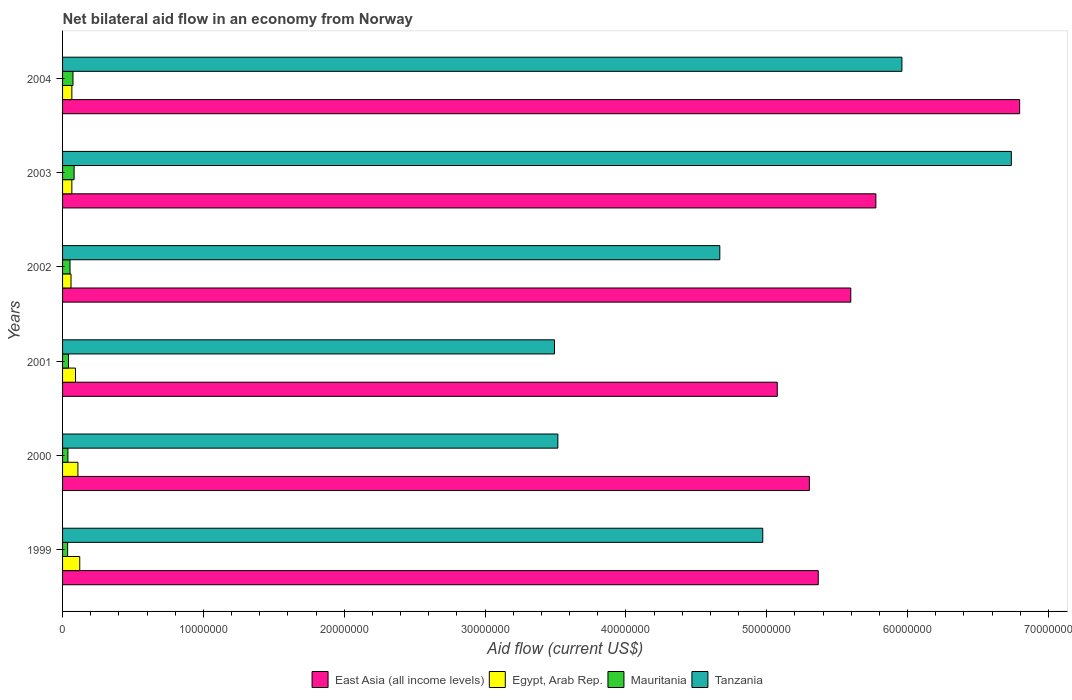How many different coloured bars are there?
Give a very brief answer. 4. How many groups of bars are there?
Offer a terse response. 6. How many bars are there on the 5th tick from the top?
Your answer should be very brief. 4. How many bars are there on the 5th tick from the bottom?
Provide a succinct answer. 4. What is the label of the 6th group of bars from the top?
Give a very brief answer. 1999. What is the net bilateral aid flow in Mauritania in 2004?
Offer a terse response. 7.40e+05. Across all years, what is the maximum net bilateral aid flow in Tanzania?
Provide a succinct answer. 6.74e+07. Across all years, what is the minimum net bilateral aid flow in Egypt, Arab Rep.?
Ensure brevity in your answer.  6.00e+05. In which year was the net bilateral aid flow in Tanzania maximum?
Give a very brief answer. 2003. In which year was the net bilateral aid flow in Tanzania minimum?
Offer a very short reply. 2001. What is the total net bilateral aid flow in Mauritania in the graph?
Offer a terse response. 3.25e+06. What is the difference between the net bilateral aid flow in Egypt, Arab Rep. in 2001 and the net bilateral aid flow in Mauritania in 2003?
Provide a succinct answer. 1.00e+05. What is the average net bilateral aid flow in Tanzania per year?
Offer a very short reply. 4.89e+07. In the year 2002, what is the difference between the net bilateral aid flow in Tanzania and net bilateral aid flow in East Asia (all income levels)?
Your answer should be very brief. -9.30e+06. In how many years, is the net bilateral aid flow in Mauritania greater than 56000000 US$?
Offer a terse response. 0. What is the ratio of the net bilateral aid flow in East Asia (all income levels) in 2000 to that in 2001?
Offer a terse response. 1.04. Is the net bilateral aid flow in Mauritania in 2000 less than that in 2003?
Ensure brevity in your answer.  Yes. What is the difference between the highest and the lowest net bilateral aid flow in Mauritania?
Provide a short and direct response. 4.60e+05. In how many years, is the net bilateral aid flow in Egypt, Arab Rep. greater than the average net bilateral aid flow in Egypt, Arab Rep. taken over all years?
Keep it short and to the point. 3. Is the sum of the net bilateral aid flow in Egypt, Arab Rep. in 2000 and 2004 greater than the maximum net bilateral aid flow in East Asia (all income levels) across all years?
Keep it short and to the point. No. Is it the case that in every year, the sum of the net bilateral aid flow in Egypt, Arab Rep. and net bilateral aid flow in Tanzania is greater than the sum of net bilateral aid flow in Mauritania and net bilateral aid flow in East Asia (all income levels)?
Offer a terse response. No. What does the 3rd bar from the top in 2003 represents?
Offer a very short reply. Egypt, Arab Rep. What does the 3rd bar from the bottom in 2000 represents?
Ensure brevity in your answer.  Mauritania. How many bars are there?
Your answer should be very brief. 24. Are all the bars in the graph horizontal?
Your answer should be very brief. Yes. Does the graph contain any zero values?
Your answer should be very brief. No. How are the legend labels stacked?
Provide a short and direct response. Horizontal. What is the title of the graph?
Make the answer very short. Net bilateral aid flow in an economy from Norway. Does "Rwanda" appear as one of the legend labels in the graph?
Ensure brevity in your answer.  No. What is the label or title of the X-axis?
Offer a terse response. Aid flow (current US$). What is the Aid flow (current US$) in East Asia (all income levels) in 1999?
Your response must be concise. 5.37e+07. What is the Aid flow (current US$) of Egypt, Arab Rep. in 1999?
Make the answer very short. 1.22e+06. What is the Aid flow (current US$) of Mauritania in 1999?
Keep it short and to the point. 3.60e+05. What is the Aid flow (current US$) of Tanzania in 1999?
Your response must be concise. 4.97e+07. What is the Aid flow (current US$) in East Asia (all income levels) in 2000?
Your answer should be very brief. 5.30e+07. What is the Aid flow (current US$) in Egypt, Arab Rep. in 2000?
Offer a terse response. 1.09e+06. What is the Aid flow (current US$) of Mauritania in 2000?
Ensure brevity in your answer.  3.80e+05. What is the Aid flow (current US$) in Tanzania in 2000?
Provide a succinct answer. 3.52e+07. What is the Aid flow (current US$) in East Asia (all income levels) in 2001?
Keep it short and to the point. 5.08e+07. What is the Aid flow (current US$) in Egypt, Arab Rep. in 2001?
Provide a short and direct response. 9.20e+05. What is the Aid flow (current US$) in Tanzania in 2001?
Offer a terse response. 3.49e+07. What is the Aid flow (current US$) in East Asia (all income levels) in 2002?
Offer a very short reply. 5.60e+07. What is the Aid flow (current US$) in Mauritania in 2002?
Offer a very short reply. 5.30e+05. What is the Aid flow (current US$) in Tanzania in 2002?
Offer a very short reply. 4.67e+07. What is the Aid flow (current US$) of East Asia (all income levels) in 2003?
Your response must be concise. 5.78e+07. What is the Aid flow (current US$) of Mauritania in 2003?
Your answer should be compact. 8.20e+05. What is the Aid flow (current US$) of Tanzania in 2003?
Ensure brevity in your answer.  6.74e+07. What is the Aid flow (current US$) of East Asia (all income levels) in 2004?
Make the answer very short. 6.80e+07. What is the Aid flow (current US$) in Mauritania in 2004?
Offer a very short reply. 7.40e+05. What is the Aid flow (current US$) of Tanzania in 2004?
Your answer should be compact. 5.96e+07. Across all years, what is the maximum Aid flow (current US$) of East Asia (all income levels)?
Provide a short and direct response. 6.80e+07. Across all years, what is the maximum Aid flow (current US$) of Egypt, Arab Rep.?
Provide a short and direct response. 1.22e+06. Across all years, what is the maximum Aid flow (current US$) of Mauritania?
Give a very brief answer. 8.20e+05. Across all years, what is the maximum Aid flow (current US$) in Tanzania?
Offer a terse response. 6.74e+07. Across all years, what is the minimum Aid flow (current US$) in East Asia (all income levels)?
Make the answer very short. 5.08e+07. Across all years, what is the minimum Aid flow (current US$) in Mauritania?
Offer a terse response. 3.60e+05. Across all years, what is the minimum Aid flow (current US$) in Tanzania?
Offer a very short reply. 3.49e+07. What is the total Aid flow (current US$) of East Asia (all income levels) in the graph?
Keep it short and to the point. 3.39e+08. What is the total Aid flow (current US$) in Egypt, Arab Rep. in the graph?
Your response must be concise. 5.15e+06. What is the total Aid flow (current US$) in Mauritania in the graph?
Ensure brevity in your answer.  3.25e+06. What is the total Aid flow (current US$) of Tanzania in the graph?
Your answer should be very brief. 2.93e+08. What is the difference between the Aid flow (current US$) of East Asia (all income levels) in 1999 and that in 2000?
Offer a very short reply. 6.30e+05. What is the difference between the Aid flow (current US$) of Mauritania in 1999 and that in 2000?
Provide a succinct answer. -2.00e+04. What is the difference between the Aid flow (current US$) in Tanzania in 1999 and that in 2000?
Your answer should be compact. 1.46e+07. What is the difference between the Aid flow (current US$) in East Asia (all income levels) in 1999 and that in 2001?
Provide a short and direct response. 2.91e+06. What is the difference between the Aid flow (current US$) of Mauritania in 1999 and that in 2001?
Ensure brevity in your answer.  -6.00e+04. What is the difference between the Aid flow (current US$) of Tanzania in 1999 and that in 2001?
Keep it short and to the point. 1.48e+07. What is the difference between the Aid flow (current US$) in East Asia (all income levels) in 1999 and that in 2002?
Ensure brevity in your answer.  -2.31e+06. What is the difference between the Aid flow (current US$) in Egypt, Arab Rep. in 1999 and that in 2002?
Offer a very short reply. 6.20e+05. What is the difference between the Aid flow (current US$) of Mauritania in 1999 and that in 2002?
Make the answer very short. -1.70e+05. What is the difference between the Aid flow (current US$) of Tanzania in 1999 and that in 2002?
Provide a succinct answer. 3.05e+06. What is the difference between the Aid flow (current US$) in East Asia (all income levels) in 1999 and that in 2003?
Keep it short and to the point. -4.09e+06. What is the difference between the Aid flow (current US$) in Egypt, Arab Rep. in 1999 and that in 2003?
Offer a very short reply. 5.60e+05. What is the difference between the Aid flow (current US$) in Mauritania in 1999 and that in 2003?
Offer a very short reply. -4.60e+05. What is the difference between the Aid flow (current US$) of Tanzania in 1999 and that in 2003?
Make the answer very short. -1.76e+07. What is the difference between the Aid flow (current US$) of East Asia (all income levels) in 1999 and that in 2004?
Provide a short and direct response. -1.43e+07. What is the difference between the Aid flow (current US$) in Egypt, Arab Rep. in 1999 and that in 2004?
Give a very brief answer. 5.60e+05. What is the difference between the Aid flow (current US$) in Mauritania in 1999 and that in 2004?
Offer a terse response. -3.80e+05. What is the difference between the Aid flow (current US$) in Tanzania in 1999 and that in 2004?
Offer a terse response. -9.88e+06. What is the difference between the Aid flow (current US$) in East Asia (all income levels) in 2000 and that in 2001?
Your answer should be compact. 2.28e+06. What is the difference between the Aid flow (current US$) of Egypt, Arab Rep. in 2000 and that in 2001?
Make the answer very short. 1.70e+05. What is the difference between the Aid flow (current US$) of Tanzania in 2000 and that in 2001?
Your answer should be compact. 2.40e+05. What is the difference between the Aid flow (current US$) of East Asia (all income levels) in 2000 and that in 2002?
Make the answer very short. -2.94e+06. What is the difference between the Aid flow (current US$) in Tanzania in 2000 and that in 2002?
Offer a terse response. -1.15e+07. What is the difference between the Aid flow (current US$) in East Asia (all income levels) in 2000 and that in 2003?
Provide a short and direct response. -4.72e+06. What is the difference between the Aid flow (current US$) of Egypt, Arab Rep. in 2000 and that in 2003?
Your answer should be very brief. 4.30e+05. What is the difference between the Aid flow (current US$) of Mauritania in 2000 and that in 2003?
Offer a terse response. -4.40e+05. What is the difference between the Aid flow (current US$) of Tanzania in 2000 and that in 2003?
Make the answer very short. -3.22e+07. What is the difference between the Aid flow (current US$) in East Asia (all income levels) in 2000 and that in 2004?
Keep it short and to the point. -1.49e+07. What is the difference between the Aid flow (current US$) of Mauritania in 2000 and that in 2004?
Your response must be concise. -3.60e+05. What is the difference between the Aid flow (current US$) in Tanzania in 2000 and that in 2004?
Your answer should be very brief. -2.44e+07. What is the difference between the Aid flow (current US$) in East Asia (all income levels) in 2001 and that in 2002?
Give a very brief answer. -5.22e+06. What is the difference between the Aid flow (current US$) of Egypt, Arab Rep. in 2001 and that in 2002?
Your answer should be very brief. 3.20e+05. What is the difference between the Aid flow (current US$) in Mauritania in 2001 and that in 2002?
Ensure brevity in your answer.  -1.10e+05. What is the difference between the Aid flow (current US$) in Tanzania in 2001 and that in 2002?
Offer a terse response. -1.17e+07. What is the difference between the Aid flow (current US$) of East Asia (all income levels) in 2001 and that in 2003?
Ensure brevity in your answer.  -7.00e+06. What is the difference between the Aid flow (current US$) of Egypt, Arab Rep. in 2001 and that in 2003?
Provide a succinct answer. 2.60e+05. What is the difference between the Aid flow (current US$) in Mauritania in 2001 and that in 2003?
Offer a very short reply. -4.00e+05. What is the difference between the Aid flow (current US$) in Tanzania in 2001 and that in 2003?
Make the answer very short. -3.24e+07. What is the difference between the Aid flow (current US$) in East Asia (all income levels) in 2001 and that in 2004?
Your response must be concise. -1.72e+07. What is the difference between the Aid flow (current US$) in Mauritania in 2001 and that in 2004?
Give a very brief answer. -3.20e+05. What is the difference between the Aid flow (current US$) of Tanzania in 2001 and that in 2004?
Keep it short and to the point. -2.47e+07. What is the difference between the Aid flow (current US$) of East Asia (all income levels) in 2002 and that in 2003?
Provide a short and direct response. -1.78e+06. What is the difference between the Aid flow (current US$) in Mauritania in 2002 and that in 2003?
Offer a very short reply. -2.90e+05. What is the difference between the Aid flow (current US$) of Tanzania in 2002 and that in 2003?
Offer a very short reply. -2.07e+07. What is the difference between the Aid flow (current US$) of East Asia (all income levels) in 2002 and that in 2004?
Your response must be concise. -1.20e+07. What is the difference between the Aid flow (current US$) in Egypt, Arab Rep. in 2002 and that in 2004?
Ensure brevity in your answer.  -6.00e+04. What is the difference between the Aid flow (current US$) in Mauritania in 2002 and that in 2004?
Offer a terse response. -2.10e+05. What is the difference between the Aid flow (current US$) of Tanzania in 2002 and that in 2004?
Make the answer very short. -1.29e+07. What is the difference between the Aid flow (current US$) of East Asia (all income levels) in 2003 and that in 2004?
Make the answer very short. -1.02e+07. What is the difference between the Aid flow (current US$) of Egypt, Arab Rep. in 2003 and that in 2004?
Give a very brief answer. 0. What is the difference between the Aid flow (current US$) in Mauritania in 2003 and that in 2004?
Offer a terse response. 8.00e+04. What is the difference between the Aid flow (current US$) in Tanzania in 2003 and that in 2004?
Give a very brief answer. 7.77e+06. What is the difference between the Aid flow (current US$) in East Asia (all income levels) in 1999 and the Aid flow (current US$) in Egypt, Arab Rep. in 2000?
Your answer should be very brief. 5.26e+07. What is the difference between the Aid flow (current US$) of East Asia (all income levels) in 1999 and the Aid flow (current US$) of Mauritania in 2000?
Make the answer very short. 5.33e+07. What is the difference between the Aid flow (current US$) of East Asia (all income levels) in 1999 and the Aid flow (current US$) of Tanzania in 2000?
Your answer should be very brief. 1.85e+07. What is the difference between the Aid flow (current US$) of Egypt, Arab Rep. in 1999 and the Aid flow (current US$) of Mauritania in 2000?
Give a very brief answer. 8.40e+05. What is the difference between the Aid flow (current US$) in Egypt, Arab Rep. in 1999 and the Aid flow (current US$) in Tanzania in 2000?
Your response must be concise. -3.40e+07. What is the difference between the Aid flow (current US$) of Mauritania in 1999 and the Aid flow (current US$) of Tanzania in 2000?
Your answer should be very brief. -3.48e+07. What is the difference between the Aid flow (current US$) in East Asia (all income levels) in 1999 and the Aid flow (current US$) in Egypt, Arab Rep. in 2001?
Offer a terse response. 5.27e+07. What is the difference between the Aid flow (current US$) of East Asia (all income levels) in 1999 and the Aid flow (current US$) of Mauritania in 2001?
Provide a short and direct response. 5.32e+07. What is the difference between the Aid flow (current US$) in East Asia (all income levels) in 1999 and the Aid flow (current US$) in Tanzania in 2001?
Provide a short and direct response. 1.87e+07. What is the difference between the Aid flow (current US$) of Egypt, Arab Rep. in 1999 and the Aid flow (current US$) of Mauritania in 2001?
Give a very brief answer. 8.00e+05. What is the difference between the Aid flow (current US$) in Egypt, Arab Rep. in 1999 and the Aid flow (current US$) in Tanzania in 2001?
Offer a very short reply. -3.37e+07. What is the difference between the Aid flow (current US$) of Mauritania in 1999 and the Aid flow (current US$) of Tanzania in 2001?
Keep it short and to the point. -3.46e+07. What is the difference between the Aid flow (current US$) of East Asia (all income levels) in 1999 and the Aid flow (current US$) of Egypt, Arab Rep. in 2002?
Your response must be concise. 5.31e+07. What is the difference between the Aid flow (current US$) in East Asia (all income levels) in 1999 and the Aid flow (current US$) in Mauritania in 2002?
Offer a very short reply. 5.31e+07. What is the difference between the Aid flow (current US$) in East Asia (all income levels) in 1999 and the Aid flow (current US$) in Tanzania in 2002?
Make the answer very short. 6.99e+06. What is the difference between the Aid flow (current US$) of Egypt, Arab Rep. in 1999 and the Aid flow (current US$) of Mauritania in 2002?
Keep it short and to the point. 6.90e+05. What is the difference between the Aid flow (current US$) in Egypt, Arab Rep. in 1999 and the Aid flow (current US$) in Tanzania in 2002?
Offer a terse response. -4.54e+07. What is the difference between the Aid flow (current US$) in Mauritania in 1999 and the Aid flow (current US$) in Tanzania in 2002?
Provide a short and direct response. -4.63e+07. What is the difference between the Aid flow (current US$) in East Asia (all income levels) in 1999 and the Aid flow (current US$) in Egypt, Arab Rep. in 2003?
Your answer should be compact. 5.30e+07. What is the difference between the Aid flow (current US$) of East Asia (all income levels) in 1999 and the Aid flow (current US$) of Mauritania in 2003?
Keep it short and to the point. 5.28e+07. What is the difference between the Aid flow (current US$) in East Asia (all income levels) in 1999 and the Aid flow (current US$) in Tanzania in 2003?
Provide a succinct answer. -1.37e+07. What is the difference between the Aid flow (current US$) of Egypt, Arab Rep. in 1999 and the Aid flow (current US$) of Tanzania in 2003?
Offer a very short reply. -6.62e+07. What is the difference between the Aid flow (current US$) in Mauritania in 1999 and the Aid flow (current US$) in Tanzania in 2003?
Provide a short and direct response. -6.70e+07. What is the difference between the Aid flow (current US$) in East Asia (all income levels) in 1999 and the Aid flow (current US$) in Egypt, Arab Rep. in 2004?
Offer a terse response. 5.30e+07. What is the difference between the Aid flow (current US$) of East Asia (all income levels) in 1999 and the Aid flow (current US$) of Mauritania in 2004?
Your answer should be very brief. 5.29e+07. What is the difference between the Aid flow (current US$) of East Asia (all income levels) in 1999 and the Aid flow (current US$) of Tanzania in 2004?
Provide a short and direct response. -5.94e+06. What is the difference between the Aid flow (current US$) in Egypt, Arab Rep. in 1999 and the Aid flow (current US$) in Tanzania in 2004?
Offer a terse response. -5.84e+07. What is the difference between the Aid flow (current US$) of Mauritania in 1999 and the Aid flow (current US$) of Tanzania in 2004?
Your answer should be compact. -5.92e+07. What is the difference between the Aid flow (current US$) of East Asia (all income levels) in 2000 and the Aid flow (current US$) of Egypt, Arab Rep. in 2001?
Your answer should be very brief. 5.21e+07. What is the difference between the Aid flow (current US$) of East Asia (all income levels) in 2000 and the Aid flow (current US$) of Mauritania in 2001?
Your answer should be compact. 5.26e+07. What is the difference between the Aid flow (current US$) of East Asia (all income levels) in 2000 and the Aid flow (current US$) of Tanzania in 2001?
Your answer should be compact. 1.81e+07. What is the difference between the Aid flow (current US$) of Egypt, Arab Rep. in 2000 and the Aid flow (current US$) of Mauritania in 2001?
Make the answer very short. 6.70e+05. What is the difference between the Aid flow (current US$) in Egypt, Arab Rep. in 2000 and the Aid flow (current US$) in Tanzania in 2001?
Offer a terse response. -3.38e+07. What is the difference between the Aid flow (current US$) in Mauritania in 2000 and the Aid flow (current US$) in Tanzania in 2001?
Keep it short and to the point. -3.46e+07. What is the difference between the Aid flow (current US$) of East Asia (all income levels) in 2000 and the Aid flow (current US$) of Egypt, Arab Rep. in 2002?
Make the answer very short. 5.24e+07. What is the difference between the Aid flow (current US$) of East Asia (all income levels) in 2000 and the Aid flow (current US$) of Mauritania in 2002?
Ensure brevity in your answer.  5.25e+07. What is the difference between the Aid flow (current US$) of East Asia (all income levels) in 2000 and the Aid flow (current US$) of Tanzania in 2002?
Make the answer very short. 6.36e+06. What is the difference between the Aid flow (current US$) in Egypt, Arab Rep. in 2000 and the Aid flow (current US$) in Mauritania in 2002?
Offer a very short reply. 5.60e+05. What is the difference between the Aid flow (current US$) in Egypt, Arab Rep. in 2000 and the Aid flow (current US$) in Tanzania in 2002?
Your response must be concise. -4.56e+07. What is the difference between the Aid flow (current US$) in Mauritania in 2000 and the Aid flow (current US$) in Tanzania in 2002?
Your response must be concise. -4.63e+07. What is the difference between the Aid flow (current US$) of East Asia (all income levels) in 2000 and the Aid flow (current US$) of Egypt, Arab Rep. in 2003?
Your answer should be compact. 5.24e+07. What is the difference between the Aid flow (current US$) in East Asia (all income levels) in 2000 and the Aid flow (current US$) in Mauritania in 2003?
Ensure brevity in your answer.  5.22e+07. What is the difference between the Aid flow (current US$) in East Asia (all income levels) in 2000 and the Aid flow (current US$) in Tanzania in 2003?
Keep it short and to the point. -1.43e+07. What is the difference between the Aid flow (current US$) of Egypt, Arab Rep. in 2000 and the Aid flow (current US$) of Mauritania in 2003?
Offer a very short reply. 2.70e+05. What is the difference between the Aid flow (current US$) in Egypt, Arab Rep. in 2000 and the Aid flow (current US$) in Tanzania in 2003?
Provide a short and direct response. -6.63e+07. What is the difference between the Aid flow (current US$) of Mauritania in 2000 and the Aid flow (current US$) of Tanzania in 2003?
Ensure brevity in your answer.  -6.70e+07. What is the difference between the Aid flow (current US$) in East Asia (all income levels) in 2000 and the Aid flow (current US$) in Egypt, Arab Rep. in 2004?
Your answer should be compact. 5.24e+07. What is the difference between the Aid flow (current US$) of East Asia (all income levels) in 2000 and the Aid flow (current US$) of Mauritania in 2004?
Keep it short and to the point. 5.23e+07. What is the difference between the Aid flow (current US$) in East Asia (all income levels) in 2000 and the Aid flow (current US$) in Tanzania in 2004?
Keep it short and to the point. -6.57e+06. What is the difference between the Aid flow (current US$) in Egypt, Arab Rep. in 2000 and the Aid flow (current US$) in Mauritania in 2004?
Offer a terse response. 3.50e+05. What is the difference between the Aid flow (current US$) in Egypt, Arab Rep. in 2000 and the Aid flow (current US$) in Tanzania in 2004?
Provide a short and direct response. -5.85e+07. What is the difference between the Aid flow (current US$) in Mauritania in 2000 and the Aid flow (current US$) in Tanzania in 2004?
Ensure brevity in your answer.  -5.92e+07. What is the difference between the Aid flow (current US$) of East Asia (all income levels) in 2001 and the Aid flow (current US$) of Egypt, Arab Rep. in 2002?
Keep it short and to the point. 5.02e+07. What is the difference between the Aid flow (current US$) in East Asia (all income levels) in 2001 and the Aid flow (current US$) in Mauritania in 2002?
Your answer should be compact. 5.02e+07. What is the difference between the Aid flow (current US$) in East Asia (all income levels) in 2001 and the Aid flow (current US$) in Tanzania in 2002?
Make the answer very short. 4.08e+06. What is the difference between the Aid flow (current US$) in Egypt, Arab Rep. in 2001 and the Aid flow (current US$) in Mauritania in 2002?
Your answer should be compact. 3.90e+05. What is the difference between the Aid flow (current US$) in Egypt, Arab Rep. in 2001 and the Aid flow (current US$) in Tanzania in 2002?
Make the answer very short. -4.58e+07. What is the difference between the Aid flow (current US$) of Mauritania in 2001 and the Aid flow (current US$) of Tanzania in 2002?
Give a very brief answer. -4.62e+07. What is the difference between the Aid flow (current US$) in East Asia (all income levels) in 2001 and the Aid flow (current US$) in Egypt, Arab Rep. in 2003?
Ensure brevity in your answer.  5.01e+07. What is the difference between the Aid flow (current US$) in East Asia (all income levels) in 2001 and the Aid flow (current US$) in Mauritania in 2003?
Your response must be concise. 4.99e+07. What is the difference between the Aid flow (current US$) in East Asia (all income levels) in 2001 and the Aid flow (current US$) in Tanzania in 2003?
Provide a short and direct response. -1.66e+07. What is the difference between the Aid flow (current US$) of Egypt, Arab Rep. in 2001 and the Aid flow (current US$) of Mauritania in 2003?
Your answer should be compact. 1.00e+05. What is the difference between the Aid flow (current US$) in Egypt, Arab Rep. in 2001 and the Aid flow (current US$) in Tanzania in 2003?
Provide a short and direct response. -6.64e+07. What is the difference between the Aid flow (current US$) in Mauritania in 2001 and the Aid flow (current US$) in Tanzania in 2003?
Your answer should be compact. -6.70e+07. What is the difference between the Aid flow (current US$) of East Asia (all income levels) in 2001 and the Aid flow (current US$) of Egypt, Arab Rep. in 2004?
Offer a very short reply. 5.01e+07. What is the difference between the Aid flow (current US$) of East Asia (all income levels) in 2001 and the Aid flow (current US$) of Mauritania in 2004?
Keep it short and to the point. 5.00e+07. What is the difference between the Aid flow (current US$) of East Asia (all income levels) in 2001 and the Aid flow (current US$) of Tanzania in 2004?
Provide a succinct answer. -8.85e+06. What is the difference between the Aid flow (current US$) in Egypt, Arab Rep. in 2001 and the Aid flow (current US$) in Mauritania in 2004?
Your answer should be compact. 1.80e+05. What is the difference between the Aid flow (current US$) of Egypt, Arab Rep. in 2001 and the Aid flow (current US$) of Tanzania in 2004?
Give a very brief answer. -5.87e+07. What is the difference between the Aid flow (current US$) in Mauritania in 2001 and the Aid flow (current US$) in Tanzania in 2004?
Your response must be concise. -5.92e+07. What is the difference between the Aid flow (current US$) of East Asia (all income levels) in 2002 and the Aid flow (current US$) of Egypt, Arab Rep. in 2003?
Provide a short and direct response. 5.53e+07. What is the difference between the Aid flow (current US$) of East Asia (all income levels) in 2002 and the Aid flow (current US$) of Mauritania in 2003?
Your response must be concise. 5.52e+07. What is the difference between the Aid flow (current US$) in East Asia (all income levels) in 2002 and the Aid flow (current US$) in Tanzania in 2003?
Offer a very short reply. -1.14e+07. What is the difference between the Aid flow (current US$) of Egypt, Arab Rep. in 2002 and the Aid flow (current US$) of Mauritania in 2003?
Give a very brief answer. -2.20e+05. What is the difference between the Aid flow (current US$) of Egypt, Arab Rep. in 2002 and the Aid flow (current US$) of Tanzania in 2003?
Give a very brief answer. -6.68e+07. What is the difference between the Aid flow (current US$) of Mauritania in 2002 and the Aid flow (current US$) of Tanzania in 2003?
Give a very brief answer. -6.68e+07. What is the difference between the Aid flow (current US$) in East Asia (all income levels) in 2002 and the Aid flow (current US$) in Egypt, Arab Rep. in 2004?
Make the answer very short. 5.53e+07. What is the difference between the Aid flow (current US$) of East Asia (all income levels) in 2002 and the Aid flow (current US$) of Mauritania in 2004?
Provide a short and direct response. 5.52e+07. What is the difference between the Aid flow (current US$) of East Asia (all income levels) in 2002 and the Aid flow (current US$) of Tanzania in 2004?
Provide a succinct answer. -3.63e+06. What is the difference between the Aid flow (current US$) of Egypt, Arab Rep. in 2002 and the Aid flow (current US$) of Mauritania in 2004?
Ensure brevity in your answer.  -1.40e+05. What is the difference between the Aid flow (current US$) of Egypt, Arab Rep. in 2002 and the Aid flow (current US$) of Tanzania in 2004?
Provide a short and direct response. -5.90e+07. What is the difference between the Aid flow (current US$) of Mauritania in 2002 and the Aid flow (current US$) of Tanzania in 2004?
Your response must be concise. -5.91e+07. What is the difference between the Aid flow (current US$) of East Asia (all income levels) in 2003 and the Aid flow (current US$) of Egypt, Arab Rep. in 2004?
Provide a short and direct response. 5.71e+07. What is the difference between the Aid flow (current US$) in East Asia (all income levels) in 2003 and the Aid flow (current US$) in Mauritania in 2004?
Ensure brevity in your answer.  5.70e+07. What is the difference between the Aid flow (current US$) in East Asia (all income levels) in 2003 and the Aid flow (current US$) in Tanzania in 2004?
Your answer should be very brief. -1.85e+06. What is the difference between the Aid flow (current US$) of Egypt, Arab Rep. in 2003 and the Aid flow (current US$) of Tanzania in 2004?
Provide a succinct answer. -5.89e+07. What is the difference between the Aid flow (current US$) of Mauritania in 2003 and the Aid flow (current US$) of Tanzania in 2004?
Provide a succinct answer. -5.88e+07. What is the average Aid flow (current US$) of East Asia (all income levels) per year?
Your response must be concise. 5.65e+07. What is the average Aid flow (current US$) of Egypt, Arab Rep. per year?
Your answer should be compact. 8.58e+05. What is the average Aid flow (current US$) of Mauritania per year?
Offer a terse response. 5.42e+05. What is the average Aid flow (current US$) of Tanzania per year?
Provide a short and direct response. 4.89e+07. In the year 1999, what is the difference between the Aid flow (current US$) of East Asia (all income levels) and Aid flow (current US$) of Egypt, Arab Rep.?
Keep it short and to the point. 5.24e+07. In the year 1999, what is the difference between the Aid flow (current US$) in East Asia (all income levels) and Aid flow (current US$) in Mauritania?
Your answer should be compact. 5.33e+07. In the year 1999, what is the difference between the Aid flow (current US$) of East Asia (all income levels) and Aid flow (current US$) of Tanzania?
Make the answer very short. 3.94e+06. In the year 1999, what is the difference between the Aid flow (current US$) of Egypt, Arab Rep. and Aid flow (current US$) of Mauritania?
Keep it short and to the point. 8.60e+05. In the year 1999, what is the difference between the Aid flow (current US$) in Egypt, Arab Rep. and Aid flow (current US$) in Tanzania?
Offer a terse response. -4.85e+07. In the year 1999, what is the difference between the Aid flow (current US$) of Mauritania and Aid flow (current US$) of Tanzania?
Give a very brief answer. -4.94e+07. In the year 2000, what is the difference between the Aid flow (current US$) of East Asia (all income levels) and Aid flow (current US$) of Egypt, Arab Rep.?
Offer a terse response. 5.19e+07. In the year 2000, what is the difference between the Aid flow (current US$) of East Asia (all income levels) and Aid flow (current US$) of Mauritania?
Provide a short and direct response. 5.26e+07. In the year 2000, what is the difference between the Aid flow (current US$) in East Asia (all income levels) and Aid flow (current US$) in Tanzania?
Keep it short and to the point. 1.79e+07. In the year 2000, what is the difference between the Aid flow (current US$) in Egypt, Arab Rep. and Aid flow (current US$) in Mauritania?
Your answer should be very brief. 7.10e+05. In the year 2000, what is the difference between the Aid flow (current US$) in Egypt, Arab Rep. and Aid flow (current US$) in Tanzania?
Ensure brevity in your answer.  -3.41e+07. In the year 2000, what is the difference between the Aid flow (current US$) of Mauritania and Aid flow (current US$) of Tanzania?
Provide a succinct answer. -3.48e+07. In the year 2001, what is the difference between the Aid flow (current US$) in East Asia (all income levels) and Aid flow (current US$) in Egypt, Arab Rep.?
Give a very brief answer. 4.98e+07. In the year 2001, what is the difference between the Aid flow (current US$) in East Asia (all income levels) and Aid flow (current US$) in Mauritania?
Your answer should be very brief. 5.03e+07. In the year 2001, what is the difference between the Aid flow (current US$) of East Asia (all income levels) and Aid flow (current US$) of Tanzania?
Your response must be concise. 1.58e+07. In the year 2001, what is the difference between the Aid flow (current US$) of Egypt, Arab Rep. and Aid flow (current US$) of Tanzania?
Offer a terse response. -3.40e+07. In the year 2001, what is the difference between the Aid flow (current US$) of Mauritania and Aid flow (current US$) of Tanzania?
Your answer should be compact. -3.45e+07. In the year 2002, what is the difference between the Aid flow (current US$) of East Asia (all income levels) and Aid flow (current US$) of Egypt, Arab Rep.?
Make the answer very short. 5.54e+07. In the year 2002, what is the difference between the Aid flow (current US$) of East Asia (all income levels) and Aid flow (current US$) of Mauritania?
Keep it short and to the point. 5.54e+07. In the year 2002, what is the difference between the Aid flow (current US$) in East Asia (all income levels) and Aid flow (current US$) in Tanzania?
Offer a very short reply. 9.30e+06. In the year 2002, what is the difference between the Aid flow (current US$) of Egypt, Arab Rep. and Aid flow (current US$) of Tanzania?
Provide a short and direct response. -4.61e+07. In the year 2002, what is the difference between the Aid flow (current US$) in Mauritania and Aid flow (current US$) in Tanzania?
Offer a very short reply. -4.61e+07. In the year 2003, what is the difference between the Aid flow (current US$) of East Asia (all income levels) and Aid flow (current US$) of Egypt, Arab Rep.?
Your answer should be compact. 5.71e+07. In the year 2003, what is the difference between the Aid flow (current US$) in East Asia (all income levels) and Aid flow (current US$) in Mauritania?
Provide a succinct answer. 5.69e+07. In the year 2003, what is the difference between the Aid flow (current US$) in East Asia (all income levels) and Aid flow (current US$) in Tanzania?
Your response must be concise. -9.62e+06. In the year 2003, what is the difference between the Aid flow (current US$) of Egypt, Arab Rep. and Aid flow (current US$) of Tanzania?
Your answer should be very brief. -6.67e+07. In the year 2003, what is the difference between the Aid flow (current US$) of Mauritania and Aid flow (current US$) of Tanzania?
Provide a succinct answer. -6.66e+07. In the year 2004, what is the difference between the Aid flow (current US$) of East Asia (all income levels) and Aid flow (current US$) of Egypt, Arab Rep.?
Provide a short and direct response. 6.73e+07. In the year 2004, what is the difference between the Aid flow (current US$) in East Asia (all income levels) and Aid flow (current US$) in Mauritania?
Your answer should be compact. 6.72e+07. In the year 2004, what is the difference between the Aid flow (current US$) in East Asia (all income levels) and Aid flow (current US$) in Tanzania?
Your response must be concise. 8.36e+06. In the year 2004, what is the difference between the Aid flow (current US$) of Egypt, Arab Rep. and Aid flow (current US$) of Tanzania?
Provide a short and direct response. -5.89e+07. In the year 2004, what is the difference between the Aid flow (current US$) of Mauritania and Aid flow (current US$) of Tanzania?
Provide a short and direct response. -5.89e+07. What is the ratio of the Aid flow (current US$) in East Asia (all income levels) in 1999 to that in 2000?
Offer a very short reply. 1.01. What is the ratio of the Aid flow (current US$) of Egypt, Arab Rep. in 1999 to that in 2000?
Provide a succinct answer. 1.12. What is the ratio of the Aid flow (current US$) in Mauritania in 1999 to that in 2000?
Ensure brevity in your answer.  0.95. What is the ratio of the Aid flow (current US$) in Tanzania in 1999 to that in 2000?
Keep it short and to the point. 1.41. What is the ratio of the Aid flow (current US$) in East Asia (all income levels) in 1999 to that in 2001?
Offer a very short reply. 1.06. What is the ratio of the Aid flow (current US$) in Egypt, Arab Rep. in 1999 to that in 2001?
Your answer should be compact. 1.33. What is the ratio of the Aid flow (current US$) of Mauritania in 1999 to that in 2001?
Offer a very short reply. 0.86. What is the ratio of the Aid flow (current US$) of Tanzania in 1999 to that in 2001?
Make the answer very short. 1.42. What is the ratio of the Aid flow (current US$) in East Asia (all income levels) in 1999 to that in 2002?
Give a very brief answer. 0.96. What is the ratio of the Aid flow (current US$) in Egypt, Arab Rep. in 1999 to that in 2002?
Give a very brief answer. 2.03. What is the ratio of the Aid flow (current US$) of Mauritania in 1999 to that in 2002?
Keep it short and to the point. 0.68. What is the ratio of the Aid flow (current US$) of Tanzania in 1999 to that in 2002?
Your answer should be compact. 1.07. What is the ratio of the Aid flow (current US$) in East Asia (all income levels) in 1999 to that in 2003?
Ensure brevity in your answer.  0.93. What is the ratio of the Aid flow (current US$) of Egypt, Arab Rep. in 1999 to that in 2003?
Your answer should be compact. 1.85. What is the ratio of the Aid flow (current US$) of Mauritania in 1999 to that in 2003?
Your answer should be compact. 0.44. What is the ratio of the Aid flow (current US$) in Tanzania in 1999 to that in 2003?
Offer a very short reply. 0.74. What is the ratio of the Aid flow (current US$) in East Asia (all income levels) in 1999 to that in 2004?
Your answer should be very brief. 0.79. What is the ratio of the Aid flow (current US$) of Egypt, Arab Rep. in 1999 to that in 2004?
Ensure brevity in your answer.  1.85. What is the ratio of the Aid flow (current US$) of Mauritania in 1999 to that in 2004?
Provide a short and direct response. 0.49. What is the ratio of the Aid flow (current US$) of Tanzania in 1999 to that in 2004?
Offer a terse response. 0.83. What is the ratio of the Aid flow (current US$) in East Asia (all income levels) in 2000 to that in 2001?
Give a very brief answer. 1.04. What is the ratio of the Aid flow (current US$) in Egypt, Arab Rep. in 2000 to that in 2001?
Offer a very short reply. 1.18. What is the ratio of the Aid flow (current US$) of Mauritania in 2000 to that in 2001?
Your answer should be very brief. 0.9. What is the ratio of the Aid flow (current US$) in Tanzania in 2000 to that in 2001?
Provide a short and direct response. 1.01. What is the ratio of the Aid flow (current US$) of East Asia (all income levels) in 2000 to that in 2002?
Give a very brief answer. 0.95. What is the ratio of the Aid flow (current US$) of Egypt, Arab Rep. in 2000 to that in 2002?
Your answer should be very brief. 1.82. What is the ratio of the Aid flow (current US$) in Mauritania in 2000 to that in 2002?
Make the answer very short. 0.72. What is the ratio of the Aid flow (current US$) in Tanzania in 2000 to that in 2002?
Offer a terse response. 0.75. What is the ratio of the Aid flow (current US$) in East Asia (all income levels) in 2000 to that in 2003?
Offer a terse response. 0.92. What is the ratio of the Aid flow (current US$) of Egypt, Arab Rep. in 2000 to that in 2003?
Your response must be concise. 1.65. What is the ratio of the Aid flow (current US$) in Mauritania in 2000 to that in 2003?
Make the answer very short. 0.46. What is the ratio of the Aid flow (current US$) in Tanzania in 2000 to that in 2003?
Provide a short and direct response. 0.52. What is the ratio of the Aid flow (current US$) in East Asia (all income levels) in 2000 to that in 2004?
Give a very brief answer. 0.78. What is the ratio of the Aid flow (current US$) of Egypt, Arab Rep. in 2000 to that in 2004?
Make the answer very short. 1.65. What is the ratio of the Aid flow (current US$) in Mauritania in 2000 to that in 2004?
Provide a short and direct response. 0.51. What is the ratio of the Aid flow (current US$) in Tanzania in 2000 to that in 2004?
Keep it short and to the point. 0.59. What is the ratio of the Aid flow (current US$) of East Asia (all income levels) in 2001 to that in 2002?
Provide a succinct answer. 0.91. What is the ratio of the Aid flow (current US$) in Egypt, Arab Rep. in 2001 to that in 2002?
Your response must be concise. 1.53. What is the ratio of the Aid flow (current US$) of Mauritania in 2001 to that in 2002?
Provide a succinct answer. 0.79. What is the ratio of the Aid flow (current US$) of Tanzania in 2001 to that in 2002?
Offer a terse response. 0.75. What is the ratio of the Aid flow (current US$) in East Asia (all income levels) in 2001 to that in 2003?
Offer a terse response. 0.88. What is the ratio of the Aid flow (current US$) of Egypt, Arab Rep. in 2001 to that in 2003?
Provide a short and direct response. 1.39. What is the ratio of the Aid flow (current US$) of Mauritania in 2001 to that in 2003?
Provide a short and direct response. 0.51. What is the ratio of the Aid flow (current US$) of Tanzania in 2001 to that in 2003?
Make the answer very short. 0.52. What is the ratio of the Aid flow (current US$) of East Asia (all income levels) in 2001 to that in 2004?
Your answer should be compact. 0.75. What is the ratio of the Aid flow (current US$) in Egypt, Arab Rep. in 2001 to that in 2004?
Provide a succinct answer. 1.39. What is the ratio of the Aid flow (current US$) in Mauritania in 2001 to that in 2004?
Provide a succinct answer. 0.57. What is the ratio of the Aid flow (current US$) in Tanzania in 2001 to that in 2004?
Keep it short and to the point. 0.59. What is the ratio of the Aid flow (current US$) in East Asia (all income levels) in 2002 to that in 2003?
Your response must be concise. 0.97. What is the ratio of the Aid flow (current US$) of Egypt, Arab Rep. in 2002 to that in 2003?
Provide a short and direct response. 0.91. What is the ratio of the Aid flow (current US$) in Mauritania in 2002 to that in 2003?
Your answer should be compact. 0.65. What is the ratio of the Aid flow (current US$) of Tanzania in 2002 to that in 2003?
Your answer should be compact. 0.69. What is the ratio of the Aid flow (current US$) in East Asia (all income levels) in 2002 to that in 2004?
Your answer should be very brief. 0.82. What is the ratio of the Aid flow (current US$) of Egypt, Arab Rep. in 2002 to that in 2004?
Keep it short and to the point. 0.91. What is the ratio of the Aid flow (current US$) in Mauritania in 2002 to that in 2004?
Keep it short and to the point. 0.72. What is the ratio of the Aid flow (current US$) of Tanzania in 2002 to that in 2004?
Offer a very short reply. 0.78. What is the ratio of the Aid flow (current US$) of East Asia (all income levels) in 2003 to that in 2004?
Provide a short and direct response. 0.85. What is the ratio of the Aid flow (current US$) in Egypt, Arab Rep. in 2003 to that in 2004?
Provide a short and direct response. 1. What is the ratio of the Aid flow (current US$) of Mauritania in 2003 to that in 2004?
Ensure brevity in your answer.  1.11. What is the ratio of the Aid flow (current US$) of Tanzania in 2003 to that in 2004?
Ensure brevity in your answer.  1.13. What is the difference between the highest and the second highest Aid flow (current US$) of East Asia (all income levels)?
Offer a terse response. 1.02e+07. What is the difference between the highest and the second highest Aid flow (current US$) of Tanzania?
Keep it short and to the point. 7.77e+06. What is the difference between the highest and the lowest Aid flow (current US$) of East Asia (all income levels)?
Give a very brief answer. 1.72e+07. What is the difference between the highest and the lowest Aid flow (current US$) of Egypt, Arab Rep.?
Give a very brief answer. 6.20e+05. What is the difference between the highest and the lowest Aid flow (current US$) of Mauritania?
Give a very brief answer. 4.60e+05. What is the difference between the highest and the lowest Aid flow (current US$) in Tanzania?
Give a very brief answer. 3.24e+07. 